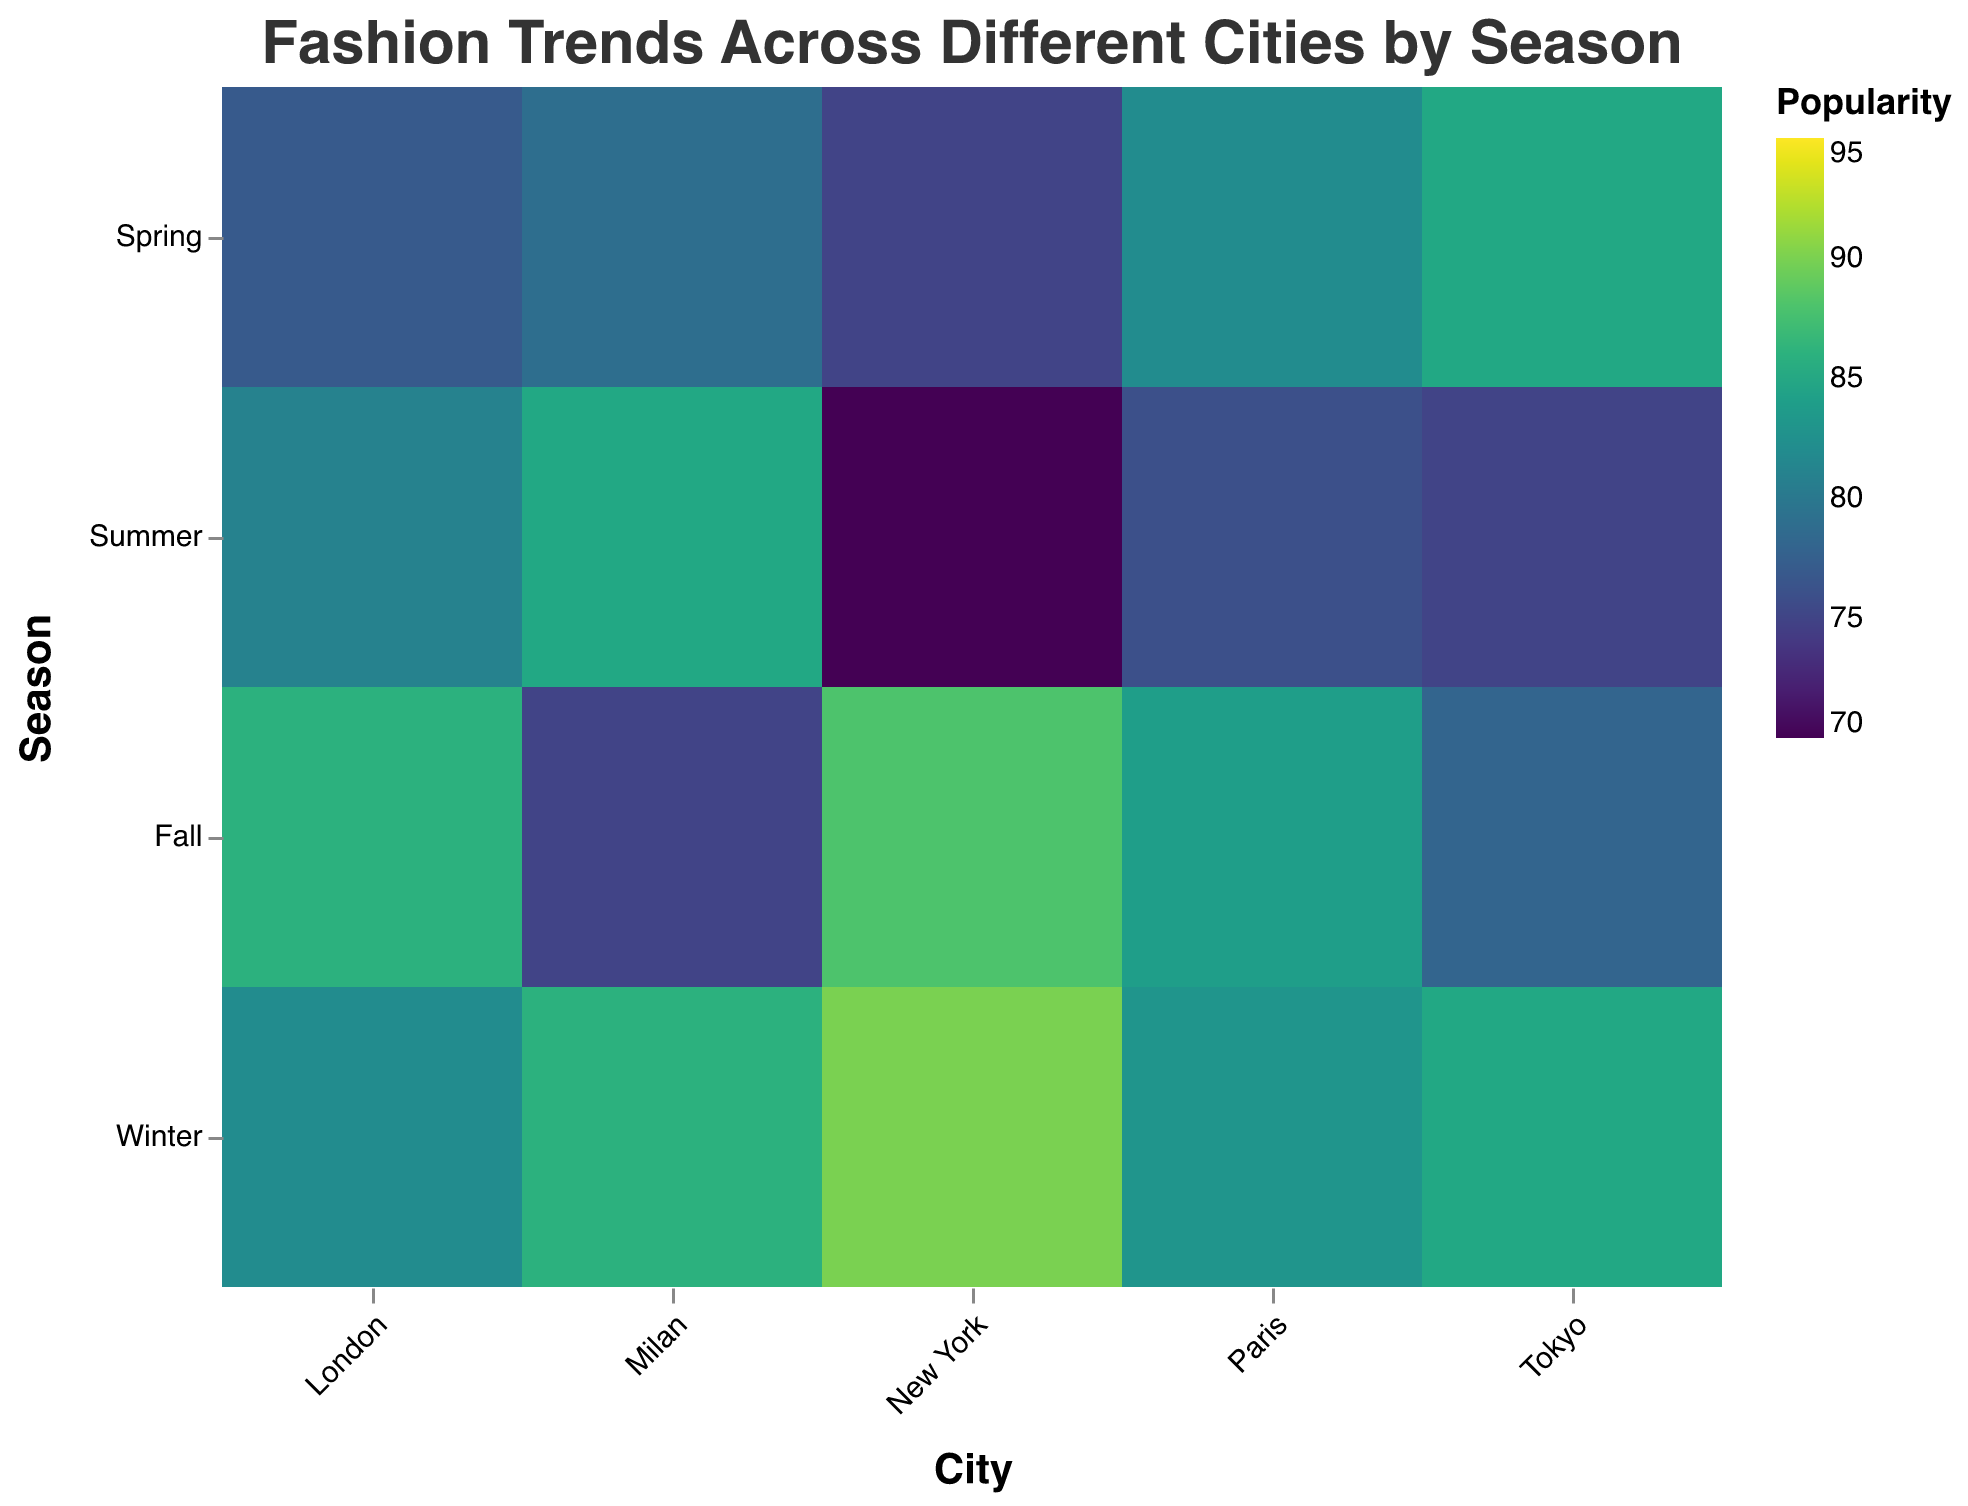What is the most popular fashion trend in New York during Winter? In New York during Winter, the popularity of each trend is represented by color intensity. Referring to the color legend, the most intense color in New York Winter corresponds to "Oversized Coats" with a popularity of 95.
Answer: Oversized Coats Which season in Paris has the highest average popularity for fashion trends? Calculate the average popularity for each season in Paris, then compare:
- Spring: (78 + 82) / 2 = 80
- Summer: (80 + 76) / 2 = 78
- Fall: (87 + 84) / 2 = 85.5
- Winter: (88 + 83) / 2 = 85.5
Both Fall and Winter have the highest average popularity of 85.5.
Answer: Fall and Winter Which city has the highest popularity score for a fashion trend in any season? Identify the highest popularity value across all cities; the most intense color on the heatmap is in New York Winter with "Oversized Coats" scoring 95.
Answer: New York Between Tokyo and Milan, which city has a higher popularity for Spring fashion trends? Compare the sum of popularity scores in Spring for both cities:
- Tokyo: 70 (Streetwear) + 85 (Kimonos) = 155
- Milan: 84 (Minimalism) + 79 (Polka Dots) = 163
Milan has a higher total popularity for Spring.
Answer: Milan What is the overall trend for Winter fashion in London compared to Winter fashion in Paris? Compare the winter trends' popularity in each city:
- London Winter: (88 + 82) / 2 = 85
- Paris Winter: (88 + 83) / 2 = 85.5
Paris has a slightly higher average popularity for Winter fashion than London.
Answer: Paris Are there any cities where Fall fashion is more popular than Winter fashion? Calculate average popularity for Fall and Winter fashion in all cities and compare:
- New York: Fall avg = (90 + 88) / 2 = 89, Winter avg = (95 + 90) / 2 = 92.5
- Paris: Fall avg = (87 + 84) / 2 = 85.5, Winter avg = (88 + 83) / 2 = 85.5
- Tokyo: Fall avg = (82 + 78) / 2 = 80, Winter avg = (80 + 85) / 2 = 82.5
- Milan: Fall avg = (89 + 75) / 2 = 82, Winter avg = (81 + 86) / 2 = 83.5
- London: Fall avg = (85 + 86) / 2 = 85.5, Winter avg = (88 + 82) / 2 = 85
No city has Fall fashion more popular than Winter fashion.
Answer: No Which season has the highest peak popularity across all cities and trends? Identify the highest score in trends for each season and compare:
- Spring: Kimonos in Tokyo (85)
- Summer: Neon Colors in New York and White Lace in Milan (both 85)
- Fall: Layering in New York (90)
- Winter: Oversized Coats in New York (95)
Winter has the highest peak popularity.
Answer: Winter Which city has the most consistent season-to-season popularity in fashion trends? Check the variance in popularity scores across each season for every city:
- New York: Variance is high (95 in Winter, 70 in Summer)
- Paris: More consistent but still fluctuates (78 to 88)
- Tokyo: Variance is considerable (70 to 85)
- Milan: Moderate variance (72 to 86)
- London: More consistent (77 to 88)
London has the most consistent popularity pattern.
Answer: London 